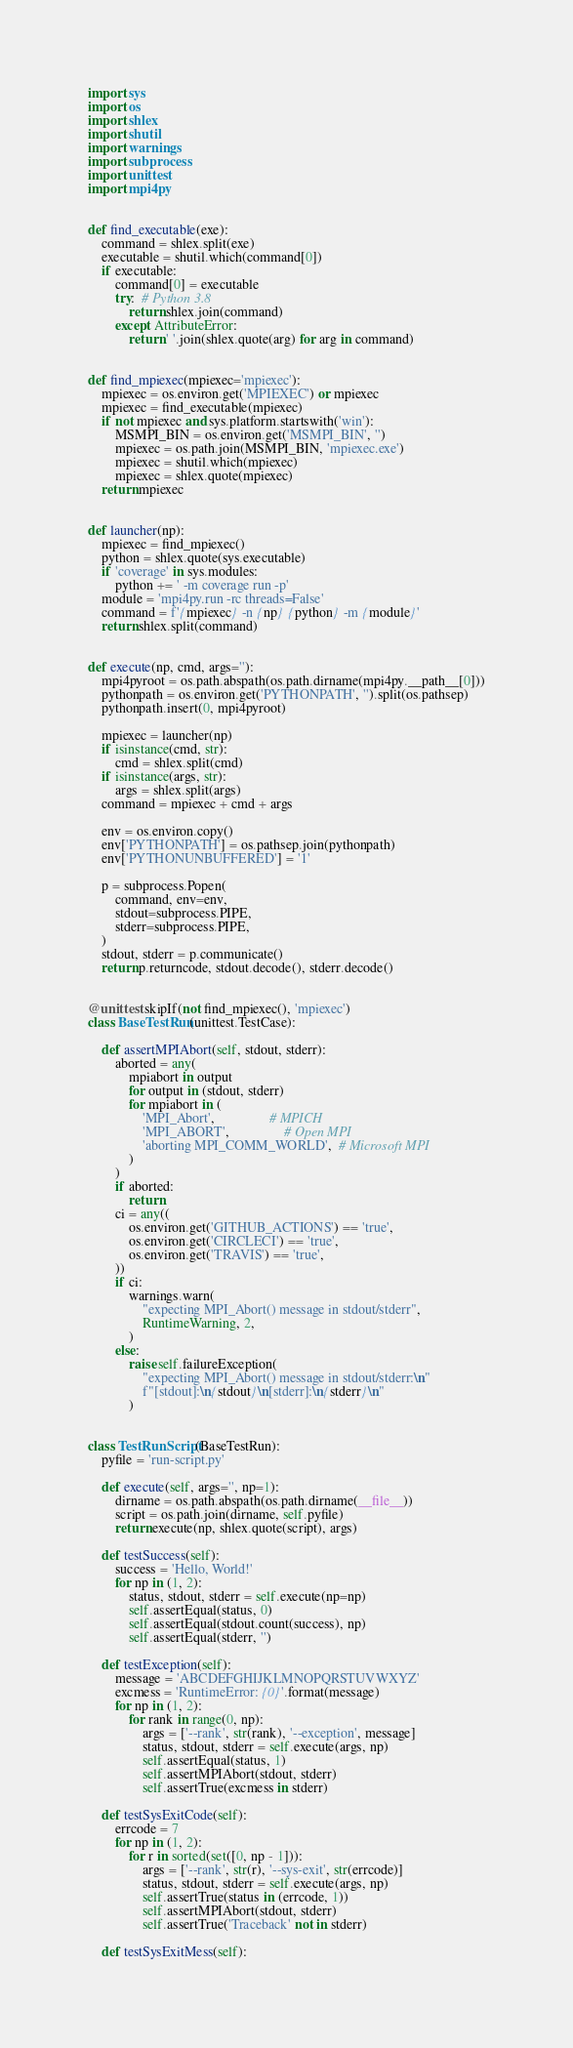Convert code to text. <code><loc_0><loc_0><loc_500><loc_500><_Python_>import sys
import os
import shlex
import shutil
import warnings
import subprocess
import unittest
import mpi4py


def find_executable(exe):
    command = shlex.split(exe)
    executable = shutil.which(command[0])
    if executable:
        command[0] = executable
        try:  # Python 3.8
            return shlex.join(command)
        except AttributeError:
            return ' '.join(shlex.quote(arg) for arg in command)


def find_mpiexec(mpiexec='mpiexec'):
    mpiexec = os.environ.get('MPIEXEC') or mpiexec
    mpiexec = find_executable(mpiexec)
    if not mpiexec and sys.platform.startswith('win'):
        MSMPI_BIN = os.environ.get('MSMPI_BIN', '')
        mpiexec = os.path.join(MSMPI_BIN, 'mpiexec.exe')
        mpiexec = shutil.which(mpiexec)
        mpiexec = shlex.quote(mpiexec)
    return mpiexec


def launcher(np):
    mpiexec = find_mpiexec()
    python = shlex.quote(sys.executable)
    if 'coverage' in sys.modules:
        python += ' -m coverage run -p'
    module = 'mpi4py.run -rc threads=False'
    command = f'{mpiexec} -n {np} {python} -m {module}'
    return shlex.split(command)


def execute(np, cmd, args=''):
    mpi4pyroot = os.path.abspath(os.path.dirname(mpi4py.__path__[0]))
    pythonpath = os.environ.get('PYTHONPATH', '').split(os.pathsep)
    pythonpath.insert(0, mpi4pyroot)

    mpiexec = launcher(np)
    if isinstance(cmd, str):
        cmd = shlex.split(cmd)
    if isinstance(args, str):
        args = shlex.split(args)
    command = mpiexec + cmd + args

    env = os.environ.copy()
    env['PYTHONPATH'] = os.pathsep.join(pythonpath)
    env['PYTHONUNBUFFERED'] = '1'

    p = subprocess.Popen(
        command, env=env,
        stdout=subprocess.PIPE,
        stderr=subprocess.PIPE,
    )
    stdout, stderr = p.communicate()
    return p.returncode, stdout.decode(), stderr.decode()


@unittest.skipIf(not find_mpiexec(), 'mpiexec')
class BaseTestRun(unittest.TestCase):

    def assertMPIAbort(self, stdout, stderr):
        aborted = any(
            mpiabort in output
            for output in (stdout, stderr)
            for mpiabort in (
                'MPI_Abort',                # MPICH
                'MPI_ABORT',                # Open MPI
                'aborting MPI_COMM_WORLD',  # Microsoft MPI
            )
        )
        if aborted:
            return
        ci = any((
            os.environ.get('GITHUB_ACTIONS') == 'true',
            os.environ.get('CIRCLECI') == 'true',
            os.environ.get('TRAVIS') == 'true',
        ))
        if ci:
            warnings.warn(
                "expecting MPI_Abort() message in stdout/stderr",
                RuntimeWarning, 2,
            )
        else:
            raise self.failureException(
                "expecting MPI_Abort() message in stdout/stderr:\n"
                f"[stdout]:\n{stdout}\n[stderr]:\n{stderr}\n"
            )


class TestRunScript(BaseTestRun):
    pyfile = 'run-script.py'

    def execute(self, args='', np=1):
        dirname = os.path.abspath(os.path.dirname(__file__))
        script = os.path.join(dirname, self.pyfile)
        return execute(np, shlex.quote(script), args)

    def testSuccess(self):
        success = 'Hello, World!'
        for np in (1, 2):
            status, stdout, stderr = self.execute(np=np)
            self.assertEqual(status, 0)
            self.assertEqual(stdout.count(success), np)
            self.assertEqual(stderr, '')

    def testException(self):
        message = 'ABCDEFGHIJKLMNOPQRSTUVWXYZ'
        excmess = 'RuntimeError: {0}'.format(message)
        for np in (1, 2):
            for rank in range(0, np):
                args = ['--rank', str(rank), '--exception', message]
                status, stdout, stderr = self.execute(args, np)
                self.assertEqual(status, 1)
                self.assertMPIAbort(stdout, stderr)
                self.assertTrue(excmess in stderr)

    def testSysExitCode(self):
        errcode = 7
        for np in (1, 2):
            for r in sorted(set([0, np - 1])):
                args = ['--rank', str(r), '--sys-exit', str(errcode)]
                status, stdout, stderr = self.execute(args, np)
                self.assertTrue(status in (errcode, 1))
                self.assertMPIAbort(stdout, stderr)
                self.assertTrue('Traceback' not in stderr)

    def testSysExitMess(self):</code> 